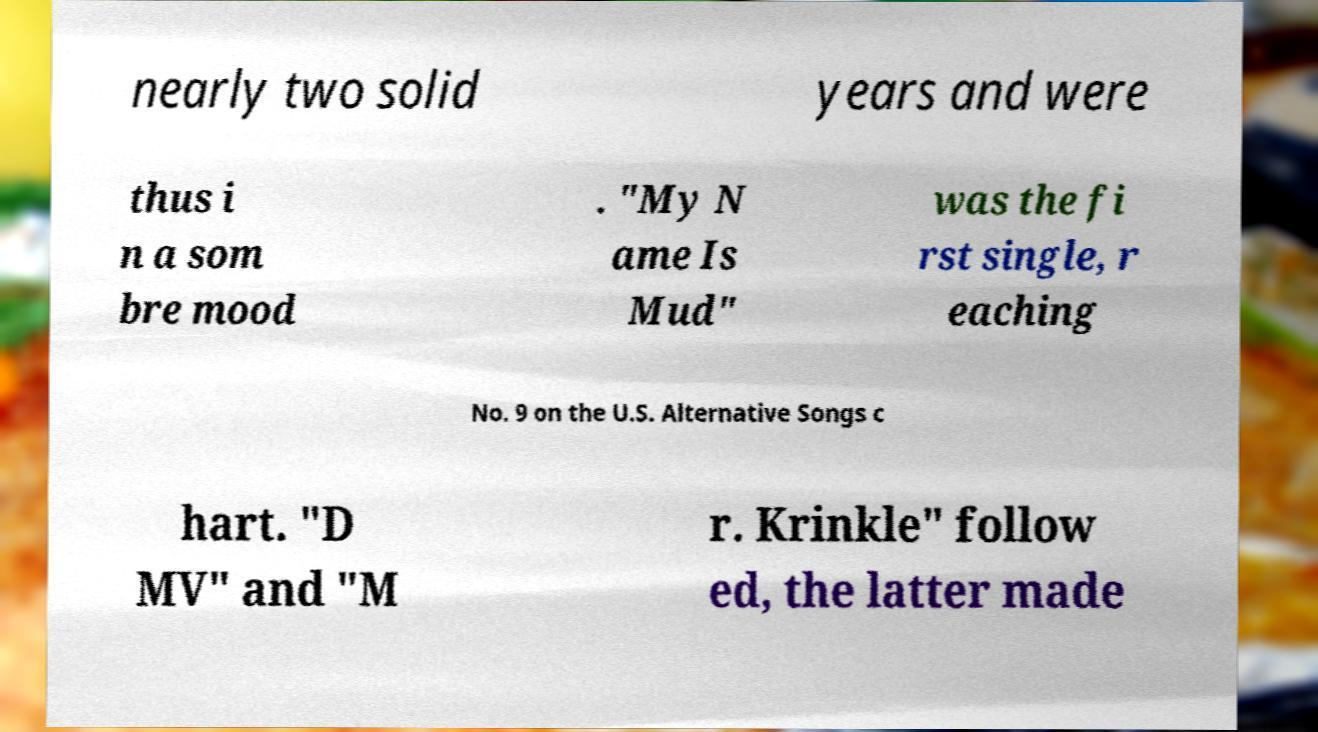I need the written content from this picture converted into text. Can you do that? nearly two solid years and were thus i n a som bre mood . "My N ame Is Mud" was the fi rst single, r eaching No. 9 on the U.S. Alternative Songs c hart. "D MV" and "M r. Krinkle" follow ed, the latter made 